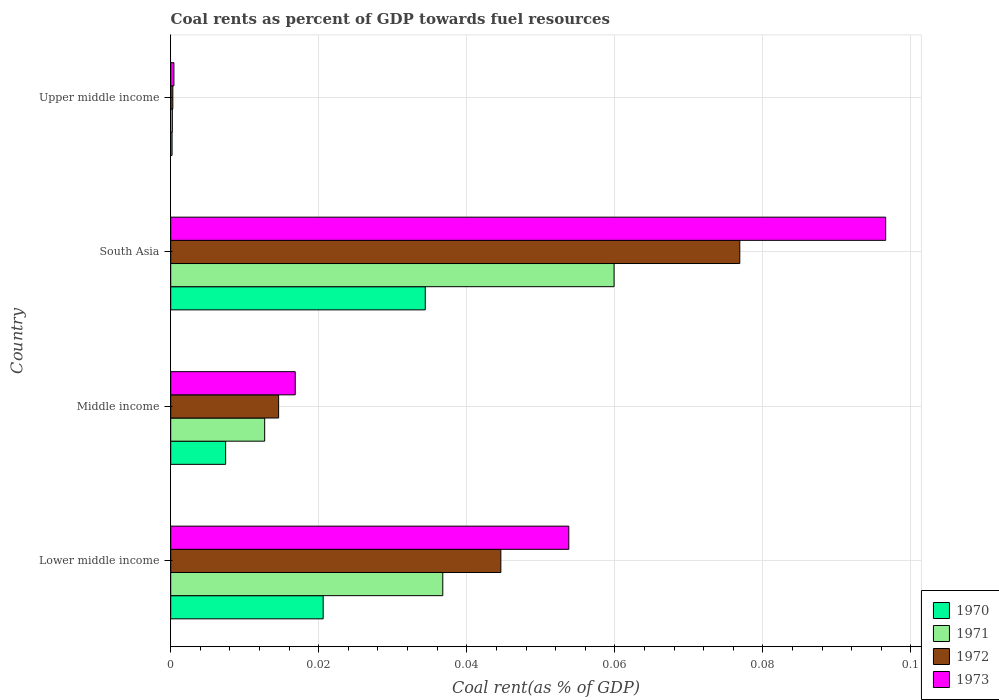How many different coloured bars are there?
Offer a very short reply. 4. How many groups of bars are there?
Keep it short and to the point. 4. Are the number of bars per tick equal to the number of legend labels?
Your response must be concise. Yes. How many bars are there on the 2nd tick from the bottom?
Your answer should be very brief. 4. What is the coal rent in 1971 in Lower middle income?
Offer a very short reply. 0.04. Across all countries, what is the maximum coal rent in 1970?
Your answer should be very brief. 0.03. Across all countries, what is the minimum coal rent in 1972?
Provide a succinct answer. 0. In which country was the coal rent in 1970 maximum?
Your answer should be very brief. South Asia. In which country was the coal rent in 1972 minimum?
Make the answer very short. Upper middle income. What is the total coal rent in 1970 in the graph?
Offer a terse response. 0.06. What is the difference between the coal rent in 1973 in South Asia and that in Upper middle income?
Your response must be concise. 0.1. What is the difference between the coal rent in 1970 in South Asia and the coal rent in 1972 in Lower middle income?
Keep it short and to the point. -0.01. What is the average coal rent in 1973 per country?
Offer a very short reply. 0.04. What is the difference between the coal rent in 1971 and coal rent in 1970 in Upper middle income?
Ensure brevity in your answer.  3.4968209641675e-5. In how many countries, is the coal rent in 1972 greater than 0.084 %?
Ensure brevity in your answer.  0. What is the ratio of the coal rent in 1971 in Lower middle income to that in Middle income?
Provide a succinct answer. 2.9. Is the difference between the coal rent in 1971 in Lower middle income and Middle income greater than the difference between the coal rent in 1970 in Lower middle income and Middle income?
Your answer should be very brief. Yes. What is the difference between the highest and the second highest coal rent in 1973?
Offer a very short reply. 0.04. What is the difference between the highest and the lowest coal rent in 1970?
Your answer should be compact. 0.03. Is the sum of the coal rent in 1971 in Middle income and South Asia greater than the maximum coal rent in 1970 across all countries?
Provide a succinct answer. Yes. Is it the case that in every country, the sum of the coal rent in 1970 and coal rent in 1973 is greater than the sum of coal rent in 1971 and coal rent in 1972?
Provide a short and direct response. No. What does the 4th bar from the top in South Asia represents?
Offer a very short reply. 1970. Is it the case that in every country, the sum of the coal rent in 1970 and coal rent in 1972 is greater than the coal rent in 1973?
Give a very brief answer. Yes. Are all the bars in the graph horizontal?
Your response must be concise. Yes. What is the difference between two consecutive major ticks on the X-axis?
Your answer should be compact. 0.02. Are the values on the major ticks of X-axis written in scientific E-notation?
Ensure brevity in your answer.  No. Does the graph contain any zero values?
Offer a very short reply. No. Where does the legend appear in the graph?
Provide a short and direct response. Bottom right. How are the legend labels stacked?
Ensure brevity in your answer.  Vertical. What is the title of the graph?
Keep it short and to the point. Coal rents as percent of GDP towards fuel resources. What is the label or title of the X-axis?
Your answer should be very brief. Coal rent(as % of GDP). What is the Coal rent(as % of GDP) of 1970 in Lower middle income?
Make the answer very short. 0.02. What is the Coal rent(as % of GDP) in 1971 in Lower middle income?
Your answer should be very brief. 0.04. What is the Coal rent(as % of GDP) of 1972 in Lower middle income?
Offer a very short reply. 0.04. What is the Coal rent(as % of GDP) of 1973 in Lower middle income?
Provide a short and direct response. 0.05. What is the Coal rent(as % of GDP) of 1970 in Middle income?
Provide a succinct answer. 0.01. What is the Coal rent(as % of GDP) in 1971 in Middle income?
Provide a succinct answer. 0.01. What is the Coal rent(as % of GDP) of 1972 in Middle income?
Give a very brief answer. 0.01. What is the Coal rent(as % of GDP) in 1973 in Middle income?
Give a very brief answer. 0.02. What is the Coal rent(as % of GDP) of 1970 in South Asia?
Offer a terse response. 0.03. What is the Coal rent(as % of GDP) of 1971 in South Asia?
Make the answer very short. 0.06. What is the Coal rent(as % of GDP) of 1972 in South Asia?
Ensure brevity in your answer.  0.08. What is the Coal rent(as % of GDP) in 1973 in South Asia?
Make the answer very short. 0.1. What is the Coal rent(as % of GDP) of 1970 in Upper middle income?
Give a very brief answer. 0. What is the Coal rent(as % of GDP) of 1971 in Upper middle income?
Provide a succinct answer. 0. What is the Coal rent(as % of GDP) of 1972 in Upper middle income?
Your answer should be compact. 0. What is the Coal rent(as % of GDP) of 1973 in Upper middle income?
Provide a short and direct response. 0. Across all countries, what is the maximum Coal rent(as % of GDP) in 1970?
Offer a terse response. 0.03. Across all countries, what is the maximum Coal rent(as % of GDP) of 1971?
Provide a short and direct response. 0.06. Across all countries, what is the maximum Coal rent(as % of GDP) in 1972?
Make the answer very short. 0.08. Across all countries, what is the maximum Coal rent(as % of GDP) of 1973?
Offer a terse response. 0.1. Across all countries, what is the minimum Coal rent(as % of GDP) in 1970?
Your answer should be compact. 0. Across all countries, what is the minimum Coal rent(as % of GDP) of 1971?
Your answer should be very brief. 0. Across all countries, what is the minimum Coal rent(as % of GDP) in 1972?
Provide a succinct answer. 0. Across all countries, what is the minimum Coal rent(as % of GDP) in 1973?
Offer a very short reply. 0. What is the total Coal rent(as % of GDP) of 1970 in the graph?
Offer a terse response. 0.06. What is the total Coal rent(as % of GDP) of 1971 in the graph?
Make the answer very short. 0.11. What is the total Coal rent(as % of GDP) in 1972 in the graph?
Your response must be concise. 0.14. What is the total Coal rent(as % of GDP) in 1973 in the graph?
Offer a very short reply. 0.17. What is the difference between the Coal rent(as % of GDP) in 1970 in Lower middle income and that in Middle income?
Keep it short and to the point. 0.01. What is the difference between the Coal rent(as % of GDP) of 1971 in Lower middle income and that in Middle income?
Provide a short and direct response. 0.02. What is the difference between the Coal rent(as % of GDP) of 1973 in Lower middle income and that in Middle income?
Provide a succinct answer. 0.04. What is the difference between the Coal rent(as % of GDP) of 1970 in Lower middle income and that in South Asia?
Your response must be concise. -0.01. What is the difference between the Coal rent(as % of GDP) in 1971 in Lower middle income and that in South Asia?
Your response must be concise. -0.02. What is the difference between the Coal rent(as % of GDP) in 1972 in Lower middle income and that in South Asia?
Your answer should be very brief. -0.03. What is the difference between the Coal rent(as % of GDP) of 1973 in Lower middle income and that in South Asia?
Offer a very short reply. -0.04. What is the difference between the Coal rent(as % of GDP) of 1970 in Lower middle income and that in Upper middle income?
Give a very brief answer. 0.02. What is the difference between the Coal rent(as % of GDP) in 1971 in Lower middle income and that in Upper middle income?
Ensure brevity in your answer.  0.04. What is the difference between the Coal rent(as % of GDP) in 1972 in Lower middle income and that in Upper middle income?
Your response must be concise. 0.04. What is the difference between the Coal rent(as % of GDP) of 1973 in Lower middle income and that in Upper middle income?
Keep it short and to the point. 0.05. What is the difference between the Coal rent(as % of GDP) of 1970 in Middle income and that in South Asia?
Offer a very short reply. -0.03. What is the difference between the Coal rent(as % of GDP) of 1971 in Middle income and that in South Asia?
Offer a terse response. -0.05. What is the difference between the Coal rent(as % of GDP) in 1972 in Middle income and that in South Asia?
Provide a succinct answer. -0.06. What is the difference between the Coal rent(as % of GDP) of 1973 in Middle income and that in South Asia?
Make the answer very short. -0.08. What is the difference between the Coal rent(as % of GDP) in 1970 in Middle income and that in Upper middle income?
Give a very brief answer. 0.01. What is the difference between the Coal rent(as % of GDP) in 1971 in Middle income and that in Upper middle income?
Ensure brevity in your answer.  0.01. What is the difference between the Coal rent(as % of GDP) in 1972 in Middle income and that in Upper middle income?
Your answer should be compact. 0.01. What is the difference between the Coal rent(as % of GDP) in 1973 in Middle income and that in Upper middle income?
Offer a terse response. 0.02. What is the difference between the Coal rent(as % of GDP) of 1970 in South Asia and that in Upper middle income?
Your answer should be very brief. 0.03. What is the difference between the Coal rent(as % of GDP) of 1971 in South Asia and that in Upper middle income?
Your answer should be compact. 0.06. What is the difference between the Coal rent(as % of GDP) of 1972 in South Asia and that in Upper middle income?
Your response must be concise. 0.08. What is the difference between the Coal rent(as % of GDP) of 1973 in South Asia and that in Upper middle income?
Keep it short and to the point. 0.1. What is the difference between the Coal rent(as % of GDP) in 1970 in Lower middle income and the Coal rent(as % of GDP) in 1971 in Middle income?
Offer a terse response. 0.01. What is the difference between the Coal rent(as % of GDP) of 1970 in Lower middle income and the Coal rent(as % of GDP) of 1972 in Middle income?
Offer a very short reply. 0.01. What is the difference between the Coal rent(as % of GDP) in 1970 in Lower middle income and the Coal rent(as % of GDP) in 1973 in Middle income?
Provide a succinct answer. 0. What is the difference between the Coal rent(as % of GDP) in 1971 in Lower middle income and the Coal rent(as % of GDP) in 1972 in Middle income?
Give a very brief answer. 0.02. What is the difference between the Coal rent(as % of GDP) of 1971 in Lower middle income and the Coal rent(as % of GDP) of 1973 in Middle income?
Your answer should be very brief. 0.02. What is the difference between the Coal rent(as % of GDP) of 1972 in Lower middle income and the Coal rent(as % of GDP) of 1973 in Middle income?
Your answer should be very brief. 0.03. What is the difference between the Coal rent(as % of GDP) of 1970 in Lower middle income and the Coal rent(as % of GDP) of 1971 in South Asia?
Provide a short and direct response. -0.04. What is the difference between the Coal rent(as % of GDP) of 1970 in Lower middle income and the Coal rent(as % of GDP) of 1972 in South Asia?
Offer a very short reply. -0.06. What is the difference between the Coal rent(as % of GDP) in 1970 in Lower middle income and the Coal rent(as % of GDP) in 1973 in South Asia?
Ensure brevity in your answer.  -0.08. What is the difference between the Coal rent(as % of GDP) in 1971 in Lower middle income and the Coal rent(as % of GDP) in 1972 in South Asia?
Make the answer very short. -0.04. What is the difference between the Coal rent(as % of GDP) of 1971 in Lower middle income and the Coal rent(as % of GDP) of 1973 in South Asia?
Provide a short and direct response. -0.06. What is the difference between the Coal rent(as % of GDP) in 1972 in Lower middle income and the Coal rent(as % of GDP) in 1973 in South Asia?
Your response must be concise. -0.05. What is the difference between the Coal rent(as % of GDP) in 1970 in Lower middle income and the Coal rent(as % of GDP) in 1971 in Upper middle income?
Your response must be concise. 0.02. What is the difference between the Coal rent(as % of GDP) in 1970 in Lower middle income and the Coal rent(as % of GDP) in 1972 in Upper middle income?
Make the answer very short. 0.02. What is the difference between the Coal rent(as % of GDP) in 1970 in Lower middle income and the Coal rent(as % of GDP) in 1973 in Upper middle income?
Offer a terse response. 0.02. What is the difference between the Coal rent(as % of GDP) of 1971 in Lower middle income and the Coal rent(as % of GDP) of 1972 in Upper middle income?
Your answer should be very brief. 0.04. What is the difference between the Coal rent(as % of GDP) in 1971 in Lower middle income and the Coal rent(as % of GDP) in 1973 in Upper middle income?
Keep it short and to the point. 0.04. What is the difference between the Coal rent(as % of GDP) in 1972 in Lower middle income and the Coal rent(as % of GDP) in 1973 in Upper middle income?
Provide a short and direct response. 0.04. What is the difference between the Coal rent(as % of GDP) in 1970 in Middle income and the Coal rent(as % of GDP) in 1971 in South Asia?
Offer a terse response. -0.05. What is the difference between the Coal rent(as % of GDP) of 1970 in Middle income and the Coal rent(as % of GDP) of 1972 in South Asia?
Your answer should be compact. -0.07. What is the difference between the Coal rent(as % of GDP) in 1970 in Middle income and the Coal rent(as % of GDP) in 1973 in South Asia?
Keep it short and to the point. -0.09. What is the difference between the Coal rent(as % of GDP) in 1971 in Middle income and the Coal rent(as % of GDP) in 1972 in South Asia?
Ensure brevity in your answer.  -0.06. What is the difference between the Coal rent(as % of GDP) of 1971 in Middle income and the Coal rent(as % of GDP) of 1973 in South Asia?
Make the answer very short. -0.08. What is the difference between the Coal rent(as % of GDP) of 1972 in Middle income and the Coal rent(as % of GDP) of 1973 in South Asia?
Your answer should be very brief. -0.08. What is the difference between the Coal rent(as % of GDP) in 1970 in Middle income and the Coal rent(as % of GDP) in 1971 in Upper middle income?
Give a very brief answer. 0.01. What is the difference between the Coal rent(as % of GDP) of 1970 in Middle income and the Coal rent(as % of GDP) of 1972 in Upper middle income?
Your answer should be compact. 0.01. What is the difference between the Coal rent(as % of GDP) in 1970 in Middle income and the Coal rent(as % of GDP) in 1973 in Upper middle income?
Provide a succinct answer. 0.01. What is the difference between the Coal rent(as % of GDP) in 1971 in Middle income and the Coal rent(as % of GDP) in 1972 in Upper middle income?
Your answer should be compact. 0.01. What is the difference between the Coal rent(as % of GDP) of 1971 in Middle income and the Coal rent(as % of GDP) of 1973 in Upper middle income?
Your answer should be very brief. 0.01. What is the difference between the Coal rent(as % of GDP) of 1972 in Middle income and the Coal rent(as % of GDP) of 1973 in Upper middle income?
Provide a succinct answer. 0.01. What is the difference between the Coal rent(as % of GDP) of 1970 in South Asia and the Coal rent(as % of GDP) of 1971 in Upper middle income?
Give a very brief answer. 0.03. What is the difference between the Coal rent(as % of GDP) of 1970 in South Asia and the Coal rent(as % of GDP) of 1972 in Upper middle income?
Provide a short and direct response. 0.03. What is the difference between the Coal rent(as % of GDP) in 1970 in South Asia and the Coal rent(as % of GDP) in 1973 in Upper middle income?
Your answer should be very brief. 0.03. What is the difference between the Coal rent(as % of GDP) in 1971 in South Asia and the Coal rent(as % of GDP) in 1972 in Upper middle income?
Offer a very short reply. 0.06. What is the difference between the Coal rent(as % of GDP) in 1971 in South Asia and the Coal rent(as % of GDP) in 1973 in Upper middle income?
Your answer should be very brief. 0.06. What is the difference between the Coal rent(as % of GDP) of 1972 in South Asia and the Coal rent(as % of GDP) of 1973 in Upper middle income?
Your answer should be compact. 0.08. What is the average Coal rent(as % of GDP) of 1970 per country?
Your answer should be very brief. 0.02. What is the average Coal rent(as % of GDP) of 1971 per country?
Make the answer very short. 0.03. What is the average Coal rent(as % of GDP) in 1972 per country?
Provide a succinct answer. 0.03. What is the average Coal rent(as % of GDP) in 1973 per country?
Provide a succinct answer. 0.04. What is the difference between the Coal rent(as % of GDP) of 1970 and Coal rent(as % of GDP) of 1971 in Lower middle income?
Your answer should be compact. -0.02. What is the difference between the Coal rent(as % of GDP) of 1970 and Coal rent(as % of GDP) of 1972 in Lower middle income?
Your answer should be very brief. -0.02. What is the difference between the Coal rent(as % of GDP) in 1970 and Coal rent(as % of GDP) in 1973 in Lower middle income?
Provide a short and direct response. -0.03. What is the difference between the Coal rent(as % of GDP) of 1971 and Coal rent(as % of GDP) of 1972 in Lower middle income?
Make the answer very short. -0.01. What is the difference between the Coal rent(as % of GDP) of 1971 and Coal rent(as % of GDP) of 1973 in Lower middle income?
Your answer should be very brief. -0.02. What is the difference between the Coal rent(as % of GDP) in 1972 and Coal rent(as % of GDP) in 1973 in Lower middle income?
Offer a very short reply. -0.01. What is the difference between the Coal rent(as % of GDP) in 1970 and Coal rent(as % of GDP) in 1971 in Middle income?
Make the answer very short. -0.01. What is the difference between the Coal rent(as % of GDP) in 1970 and Coal rent(as % of GDP) in 1972 in Middle income?
Provide a short and direct response. -0.01. What is the difference between the Coal rent(as % of GDP) of 1970 and Coal rent(as % of GDP) of 1973 in Middle income?
Ensure brevity in your answer.  -0.01. What is the difference between the Coal rent(as % of GDP) in 1971 and Coal rent(as % of GDP) in 1972 in Middle income?
Offer a terse response. -0. What is the difference between the Coal rent(as % of GDP) of 1971 and Coal rent(as % of GDP) of 1973 in Middle income?
Offer a very short reply. -0. What is the difference between the Coal rent(as % of GDP) of 1972 and Coal rent(as % of GDP) of 1973 in Middle income?
Keep it short and to the point. -0. What is the difference between the Coal rent(as % of GDP) of 1970 and Coal rent(as % of GDP) of 1971 in South Asia?
Make the answer very short. -0.03. What is the difference between the Coal rent(as % of GDP) of 1970 and Coal rent(as % of GDP) of 1972 in South Asia?
Keep it short and to the point. -0.04. What is the difference between the Coal rent(as % of GDP) of 1970 and Coal rent(as % of GDP) of 1973 in South Asia?
Give a very brief answer. -0.06. What is the difference between the Coal rent(as % of GDP) of 1971 and Coal rent(as % of GDP) of 1972 in South Asia?
Ensure brevity in your answer.  -0.02. What is the difference between the Coal rent(as % of GDP) of 1971 and Coal rent(as % of GDP) of 1973 in South Asia?
Provide a succinct answer. -0.04. What is the difference between the Coal rent(as % of GDP) in 1972 and Coal rent(as % of GDP) in 1973 in South Asia?
Make the answer very short. -0.02. What is the difference between the Coal rent(as % of GDP) of 1970 and Coal rent(as % of GDP) of 1972 in Upper middle income?
Make the answer very short. -0. What is the difference between the Coal rent(as % of GDP) in 1970 and Coal rent(as % of GDP) in 1973 in Upper middle income?
Your answer should be very brief. -0. What is the difference between the Coal rent(as % of GDP) of 1971 and Coal rent(as % of GDP) of 1972 in Upper middle income?
Keep it short and to the point. -0. What is the difference between the Coal rent(as % of GDP) of 1971 and Coal rent(as % of GDP) of 1973 in Upper middle income?
Provide a short and direct response. -0. What is the difference between the Coal rent(as % of GDP) in 1972 and Coal rent(as % of GDP) in 1973 in Upper middle income?
Give a very brief answer. -0. What is the ratio of the Coal rent(as % of GDP) of 1970 in Lower middle income to that in Middle income?
Offer a terse response. 2.78. What is the ratio of the Coal rent(as % of GDP) in 1971 in Lower middle income to that in Middle income?
Provide a succinct answer. 2.9. What is the ratio of the Coal rent(as % of GDP) of 1972 in Lower middle income to that in Middle income?
Keep it short and to the point. 3.06. What is the ratio of the Coal rent(as % of GDP) of 1973 in Lower middle income to that in Middle income?
Provide a short and direct response. 3.2. What is the ratio of the Coal rent(as % of GDP) in 1970 in Lower middle income to that in South Asia?
Your answer should be compact. 0.6. What is the ratio of the Coal rent(as % of GDP) of 1971 in Lower middle income to that in South Asia?
Give a very brief answer. 0.61. What is the ratio of the Coal rent(as % of GDP) in 1972 in Lower middle income to that in South Asia?
Make the answer very short. 0.58. What is the ratio of the Coal rent(as % of GDP) in 1973 in Lower middle income to that in South Asia?
Make the answer very short. 0.56. What is the ratio of the Coal rent(as % of GDP) in 1970 in Lower middle income to that in Upper middle income?
Your answer should be compact. 112.03. What is the ratio of the Coal rent(as % of GDP) of 1971 in Lower middle income to that in Upper middle income?
Your answer should be compact. 167.98. What is the ratio of the Coal rent(as % of GDP) of 1972 in Lower middle income to that in Upper middle income?
Provide a short and direct response. 156.82. What is the ratio of the Coal rent(as % of GDP) in 1973 in Lower middle income to that in Upper middle income?
Ensure brevity in your answer.  124.82. What is the ratio of the Coal rent(as % of GDP) in 1970 in Middle income to that in South Asia?
Provide a short and direct response. 0.22. What is the ratio of the Coal rent(as % of GDP) in 1971 in Middle income to that in South Asia?
Keep it short and to the point. 0.21. What is the ratio of the Coal rent(as % of GDP) of 1972 in Middle income to that in South Asia?
Offer a very short reply. 0.19. What is the ratio of the Coal rent(as % of GDP) of 1973 in Middle income to that in South Asia?
Provide a succinct answer. 0.17. What is the ratio of the Coal rent(as % of GDP) of 1970 in Middle income to that in Upper middle income?
Provide a succinct answer. 40.36. What is the ratio of the Coal rent(as % of GDP) in 1971 in Middle income to that in Upper middle income?
Keep it short and to the point. 58.01. What is the ratio of the Coal rent(as % of GDP) of 1972 in Middle income to that in Upper middle income?
Offer a very short reply. 51.25. What is the ratio of the Coal rent(as % of GDP) of 1973 in Middle income to that in Upper middle income?
Provide a succinct answer. 39.04. What is the ratio of the Coal rent(as % of GDP) in 1970 in South Asia to that in Upper middle income?
Your response must be concise. 187.05. What is the ratio of the Coal rent(as % of GDP) in 1971 in South Asia to that in Upper middle income?
Give a very brief answer. 273.74. What is the ratio of the Coal rent(as % of GDP) in 1972 in South Asia to that in Upper middle income?
Provide a succinct answer. 270.32. What is the ratio of the Coal rent(as % of GDP) of 1973 in South Asia to that in Upper middle income?
Provide a short and direct response. 224.18. What is the difference between the highest and the second highest Coal rent(as % of GDP) of 1970?
Offer a very short reply. 0.01. What is the difference between the highest and the second highest Coal rent(as % of GDP) of 1971?
Your response must be concise. 0.02. What is the difference between the highest and the second highest Coal rent(as % of GDP) of 1972?
Ensure brevity in your answer.  0.03. What is the difference between the highest and the second highest Coal rent(as % of GDP) in 1973?
Make the answer very short. 0.04. What is the difference between the highest and the lowest Coal rent(as % of GDP) in 1970?
Your response must be concise. 0.03. What is the difference between the highest and the lowest Coal rent(as % of GDP) in 1971?
Offer a terse response. 0.06. What is the difference between the highest and the lowest Coal rent(as % of GDP) of 1972?
Provide a succinct answer. 0.08. What is the difference between the highest and the lowest Coal rent(as % of GDP) of 1973?
Your response must be concise. 0.1. 